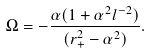<formula> <loc_0><loc_0><loc_500><loc_500>\Omega = - \frac { \alpha ( 1 + \alpha ^ { 2 } l ^ { - 2 } ) } { ( r _ { + } ^ { 2 } - \alpha ^ { 2 } ) } .</formula> 